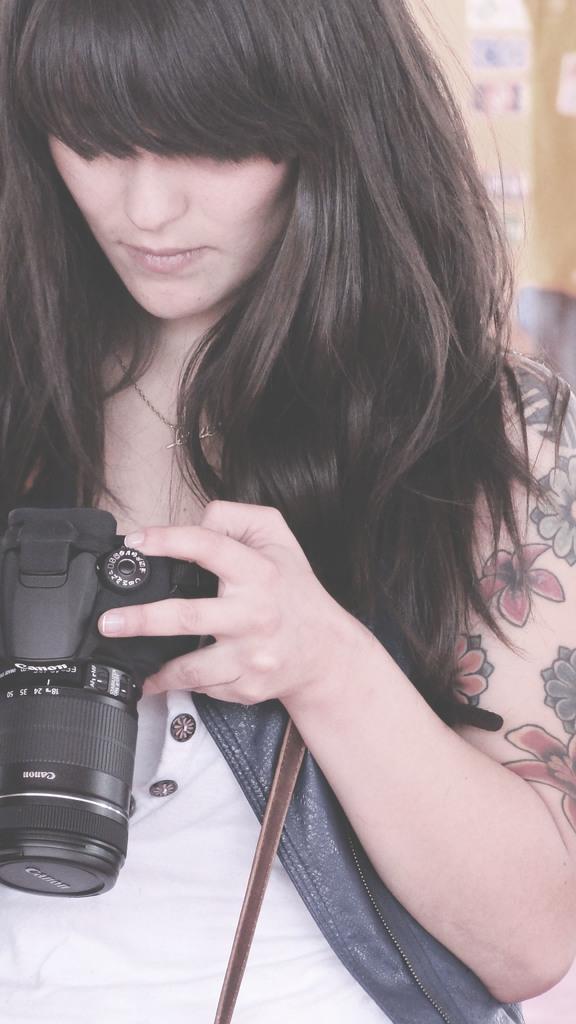Please provide a concise description of this image. In this, woman is holding a camera. She wear white color dress, blue color jacket. And there is a tattoo on his left hand. She leaves her hair. 